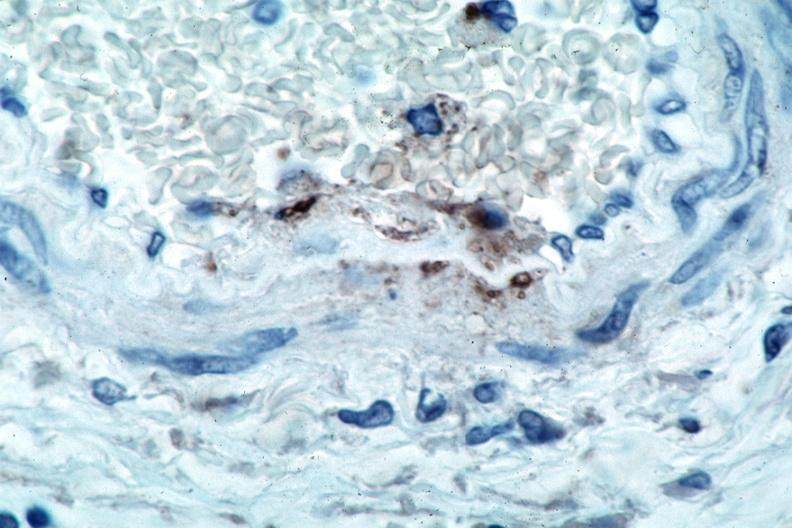what is present?
Answer the question using a single word or phrase. Cardiovascular 